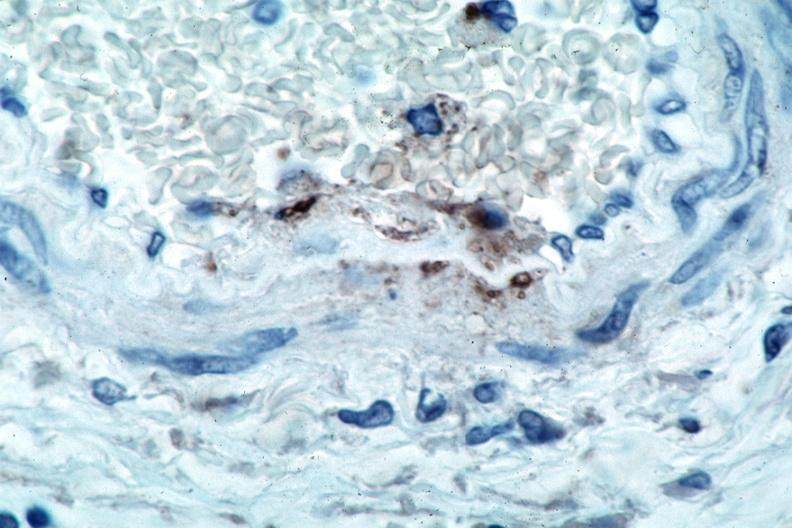what is present?
Answer the question using a single word or phrase. Cardiovascular 